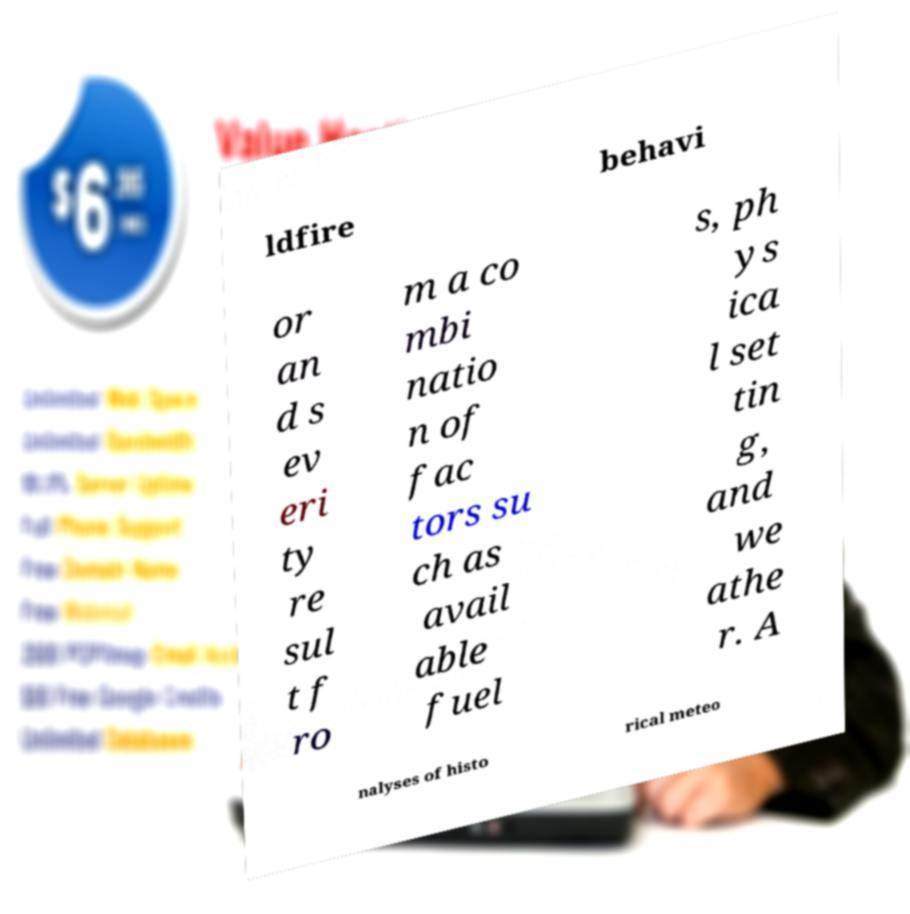What messages or text are displayed in this image? I need them in a readable, typed format. ldfire behavi or an d s ev eri ty re sul t f ro m a co mbi natio n of fac tors su ch as avail able fuel s, ph ys ica l set tin g, and we athe r. A nalyses of histo rical meteo 